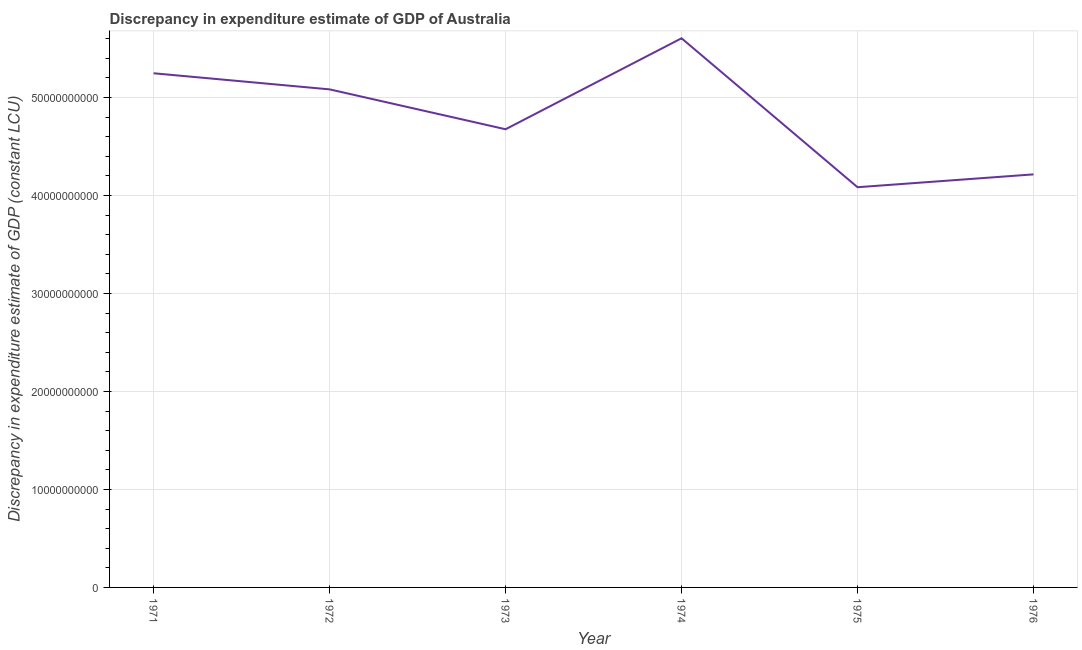What is the discrepancy in expenditure estimate of gdp in 1976?
Give a very brief answer. 4.22e+1. Across all years, what is the maximum discrepancy in expenditure estimate of gdp?
Provide a succinct answer. 5.61e+1. Across all years, what is the minimum discrepancy in expenditure estimate of gdp?
Your answer should be very brief. 4.08e+1. In which year was the discrepancy in expenditure estimate of gdp maximum?
Your response must be concise. 1974. In which year was the discrepancy in expenditure estimate of gdp minimum?
Offer a very short reply. 1975. What is the sum of the discrepancy in expenditure estimate of gdp?
Provide a succinct answer. 2.89e+11. What is the difference between the discrepancy in expenditure estimate of gdp in 1971 and 1976?
Your response must be concise. 1.03e+1. What is the average discrepancy in expenditure estimate of gdp per year?
Offer a very short reply. 4.82e+1. What is the median discrepancy in expenditure estimate of gdp?
Offer a terse response. 4.88e+1. Do a majority of the years between 1974 and 1973 (inclusive) have discrepancy in expenditure estimate of gdp greater than 36000000000 LCU?
Make the answer very short. No. What is the ratio of the discrepancy in expenditure estimate of gdp in 1975 to that in 1976?
Your answer should be compact. 0.97. What is the difference between the highest and the second highest discrepancy in expenditure estimate of gdp?
Offer a very short reply. 3.57e+09. Is the sum of the discrepancy in expenditure estimate of gdp in 1975 and 1976 greater than the maximum discrepancy in expenditure estimate of gdp across all years?
Your response must be concise. Yes. What is the difference between the highest and the lowest discrepancy in expenditure estimate of gdp?
Your answer should be compact. 1.52e+1. In how many years, is the discrepancy in expenditure estimate of gdp greater than the average discrepancy in expenditure estimate of gdp taken over all years?
Provide a short and direct response. 3. How many lines are there?
Offer a terse response. 1. How many years are there in the graph?
Offer a terse response. 6. What is the difference between two consecutive major ticks on the Y-axis?
Ensure brevity in your answer.  1.00e+1. Are the values on the major ticks of Y-axis written in scientific E-notation?
Keep it short and to the point. No. Does the graph contain any zero values?
Give a very brief answer. No. What is the title of the graph?
Your answer should be compact. Discrepancy in expenditure estimate of GDP of Australia. What is the label or title of the Y-axis?
Keep it short and to the point. Discrepancy in expenditure estimate of GDP (constant LCU). What is the Discrepancy in expenditure estimate of GDP (constant LCU) in 1971?
Give a very brief answer. 5.25e+1. What is the Discrepancy in expenditure estimate of GDP (constant LCU) in 1972?
Offer a terse response. 5.08e+1. What is the Discrepancy in expenditure estimate of GDP (constant LCU) in 1973?
Offer a terse response. 4.68e+1. What is the Discrepancy in expenditure estimate of GDP (constant LCU) of 1974?
Make the answer very short. 5.61e+1. What is the Discrepancy in expenditure estimate of GDP (constant LCU) in 1975?
Keep it short and to the point. 4.08e+1. What is the Discrepancy in expenditure estimate of GDP (constant LCU) of 1976?
Ensure brevity in your answer.  4.22e+1. What is the difference between the Discrepancy in expenditure estimate of GDP (constant LCU) in 1971 and 1972?
Offer a very short reply. 1.64e+09. What is the difference between the Discrepancy in expenditure estimate of GDP (constant LCU) in 1971 and 1973?
Ensure brevity in your answer.  5.71e+09. What is the difference between the Discrepancy in expenditure estimate of GDP (constant LCU) in 1971 and 1974?
Your answer should be very brief. -3.57e+09. What is the difference between the Discrepancy in expenditure estimate of GDP (constant LCU) in 1971 and 1975?
Make the answer very short. 1.16e+1. What is the difference between the Discrepancy in expenditure estimate of GDP (constant LCU) in 1971 and 1976?
Ensure brevity in your answer.  1.03e+1. What is the difference between the Discrepancy in expenditure estimate of GDP (constant LCU) in 1972 and 1973?
Ensure brevity in your answer.  4.07e+09. What is the difference between the Discrepancy in expenditure estimate of GDP (constant LCU) in 1972 and 1974?
Give a very brief answer. -5.22e+09. What is the difference between the Discrepancy in expenditure estimate of GDP (constant LCU) in 1972 and 1975?
Your answer should be very brief. 9.99e+09. What is the difference between the Discrepancy in expenditure estimate of GDP (constant LCU) in 1972 and 1976?
Provide a succinct answer. 8.68e+09. What is the difference between the Discrepancy in expenditure estimate of GDP (constant LCU) in 1973 and 1974?
Ensure brevity in your answer.  -9.29e+09. What is the difference between the Discrepancy in expenditure estimate of GDP (constant LCU) in 1973 and 1975?
Ensure brevity in your answer.  5.92e+09. What is the difference between the Discrepancy in expenditure estimate of GDP (constant LCU) in 1973 and 1976?
Your response must be concise. 4.61e+09. What is the difference between the Discrepancy in expenditure estimate of GDP (constant LCU) in 1974 and 1975?
Ensure brevity in your answer.  1.52e+1. What is the difference between the Discrepancy in expenditure estimate of GDP (constant LCU) in 1974 and 1976?
Offer a very short reply. 1.39e+1. What is the difference between the Discrepancy in expenditure estimate of GDP (constant LCU) in 1975 and 1976?
Keep it short and to the point. -1.31e+09. What is the ratio of the Discrepancy in expenditure estimate of GDP (constant LCU) in 1971 to that in 1972?
Keep it short and to the point. 1.03. What is the ratio of the Discrepancy in expenditure estimate of GDP (constant LCU) in 1971 to that in 1973?
Ensure brevity in your answer.  1.12. What is the ratio of the Discrepancy in expenditure estimate of GDP (constant LCU) in 1971 to that in 1974?
Offer a very short reply. 0.94. What is the ratio of the Discrepancy in expenditure estimate of GDP (constant LCU) in 1971 to that in 1975?
Provide a succinct answer. 1.28. What is the ratio of the Discrepancy in expenditure estimate of GDP (constant LCU) in 1971 to that in 1976?
Your response must be concise. 1.25. What is the ratio of the Discrepancy in expenditure estimate of GDP (constant LCU) in 1972 to that in 1973?
Give a very brief answer. 1.09. What is the ratio of the Discrepancy in expenditure estimate of GDP (constant LCU) in 1972 to that in 1974?
Your answer should be compact. 0.91. What is the ratio of the Discrepancy in expenditure estimate of GDP (constant LCU) in 1972 to that in 1975?
Give a very brief answer. 1.25. What is the ratio of the Discrepancy in expenditure estimate of GDP (constant LCU) in 1972 to that in 1976?
Your answer should be very brief. 1.21. What is the ratio of the Discrepancy in expenditure estimate of GDP (constant LCU) in 1973 to that in 1974?
Keep it short and to the point. 0.83. What is the ratio of the Discrepancy in expenditure estimate of GDP (constant LCU) in 1973 to that in 1975?
Offer a very short reply. 1.15. What is the ratio of the Discrepancy in expenditure estimate of GDP (constant LCU) in 1973 to that in 1976?
Your answer should be compact. 1.11. What is the ratio of the Discrepancy in expenditure estimate of GDP (constant LCU) in 1974 to that in 1975?
Offer a very short reply. 1.37. What is the ratio of the Discrepancy in expenditure estimate of GDP (constant LCU) in 1974 to that in 1976?
Your answer should be very brief. 1.33. 